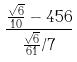<formula> <loc_0><loc_0><loc_500><loc_500>\frac { \frac { \sqrt { 6 } } { 1 0 } - 4 5 6 } { \frac { \sqrt { 6 } } { 6 1 } / 7 }</formula> 